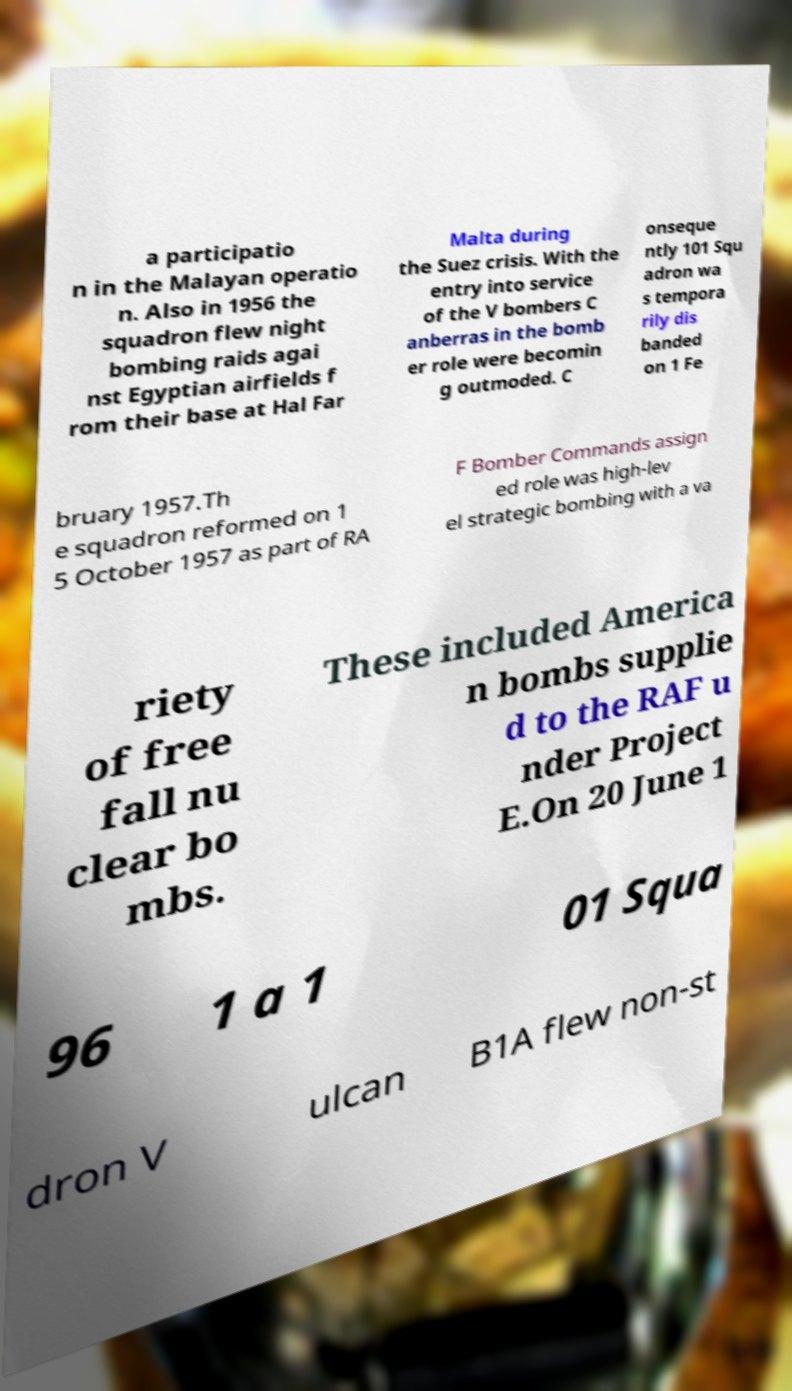Can you read and provide the text displayed in the image?This photo seems to have some interesting text. Can you extract and type it out for me? a participatio n in the Malayan operatio n. Also in 1956 the squadron flew night bombing raids agai nst Egyptian airfields f rom their base at Hal Far Malta during the Suez crisis. With the entry into service of the V bombers C anberras in the bomb er role were becomin g outmoded. C onseque ntly 101 Squ adron wa s tempora rily dis banded on 1 Fe bruary 1957.Th e squadron reformed on 1 5 October 1957 as part of RA F Bomber Commands assign ed role was high-lev el strategic bombing with a va riety of free fall nu clear bo mbs. These included America n bombs supplie d to the RAF u nder Project E.On 20 June 1 96 1 a 1 01 Squa dron V ulcan B1A flew non-st 